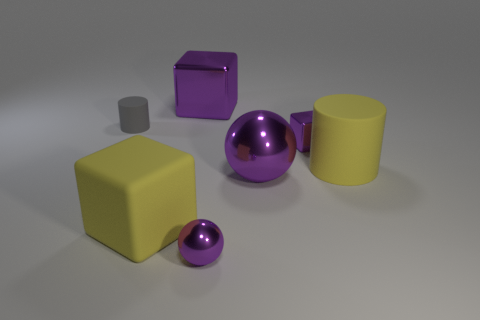How many big metal things have the same color as the large metallic block?
Your response must be concise. 1. There is a block that is left of the large purple object that is behind the tiny cylinder; what is its color?
Give a very brief answer. Yellow. There is a yellow rubber thing that is the same shape as the tiny gray matte thing; what is its size?
Provide a succinct answer. Large. Does the big rubber cylinder have the same color as the tiny metallic block?
Your answer should be compact. No. There is a purple cube behind the tiny thing that is on the left side of the tiny metal ball; what number of big rubber things are in front of it?
Your answer should be very brief. 2. Are there more big matte blocks than purple metal balls?
Offer a very short reply. No. What number of things are there?
Provide a succinct answer. 7. What is the shape of the large thing that is behind the small gray object left of the cube behind the tiny gray cylinder?
Offer a terse response. Cube. Is the number of small purple metallic objects in front of the rubber block less than the number of yellow matte things to the right of the large cylinder?
Ensure brevity in your answer.  No. Does the big purple metal object behind the small purple block have the same shape as the big purple object in front of the gray rubber object?
Your response must be concise. No. 